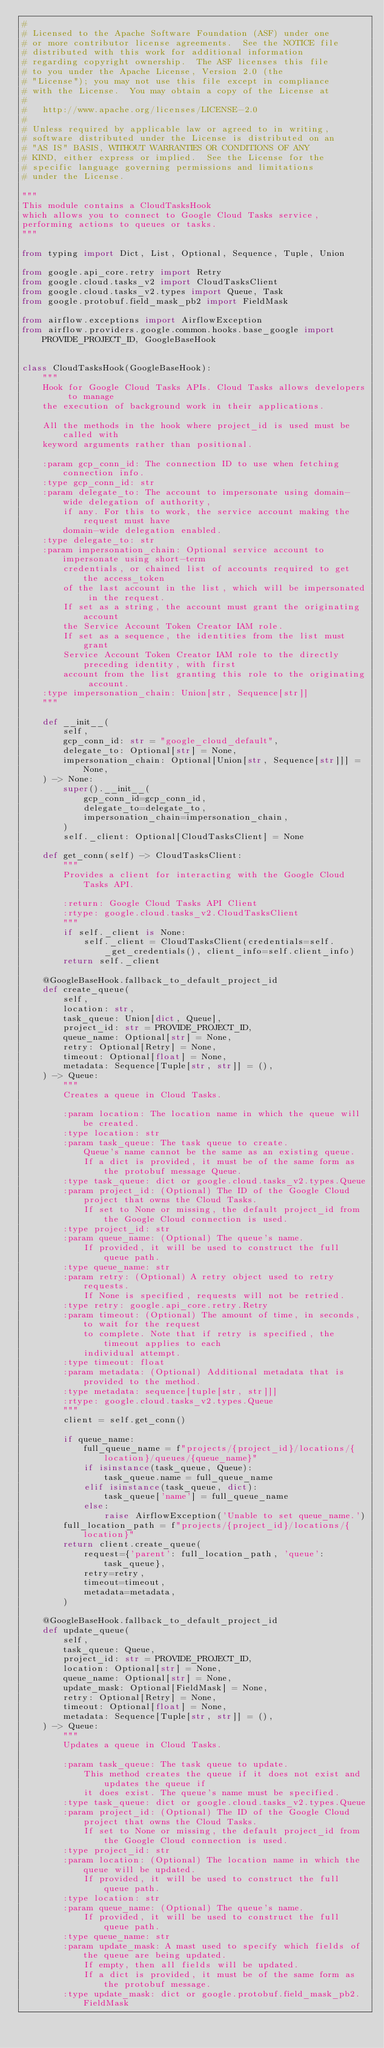Convert code to text. <code><loc_0><loc_0><loc_500><loc_500><_Python_>#
# Licensed to the Apache Software Foundation (ASF) under one
# or more contributor license agreements.  See the NOTICE file
# distributed with this work for additional information
# regarding copyright ownership.  The ASF licenses this file
# to you under the Apache License, Version 2.0 (the
# "License"); you may not use this file except in compliance
# with the License.  You may obtain a copy of the License at
#
#   http://www.apache.org/licenses/LICENSE-2.0
#
# Unless required by applicable law or agreed to in writing,
# software distributed under the License is distributed on an
# "AS IS" BASIS, WITHOUT WARRANTIES OR CONDITIONS OF ANY
# KIND, either express or implied.  See the License for the
# specific language governing permissions and limitations
# under the License.

"""
This module contains a CloudTasksHook
which allows you to connect to Google Cloud Tasks service,
performing actions to queues or tasks.
"""

from typing import Dict, List, Optional, Sequence, Tuple, Union

from google.api_core.retry import Retry
from google.cloud.tasks_v2 import CloudTasksClient
from google.cloud.tasks_v2.types import Queue, Task
from google.protobuf.field_mask_pb2 import FieldMask

from airflow.exceptions import AirflowException
from airflow.providers.google.common.hooks.base_google import PROVIDE_PROJECT_ID, GoogleBaseHook


class CloudTasksHook(GoogleBaseHook):
    """
    Hook for Google Cloud Tasks APIs. Cloud Tasks allows developers to manage
    the execution of background work in their applications.

    All the methods in the hook where project_id is used must be called with
    keyword arguments rather than positional.

    :param gcp_conn_id: The connection ID to use when fetching connection info.
    :type gcp_conn_id: str
    :param delegate_to: The account to impersonate using domain-wide delegation of authority,
        if any. For this to work, the service account making the request must have
        domain-wide delegation enabled.
    :type delegate_to: str
    :param impersonation_chain: Optional service account to impersonate using short-term
        credentials, or chained list of accounts required to get the access_token
        of the last account in the list, which will be impersonated in the request.
        If set as a string, the account must grant the originating account
        the Service Account Token Creator IAM role.
        If set as a sequence, the identities from the list must grant
        Service Account Token Creator IAM role to the directly preceding identity, with first
        account from the list granting this role to the originating account.
    :type impersonation_chain: Union[str, Sequence[str]]
    """

    def __init__(
        self,
        gcp_conn_id: str = "google_cloud_default",
        delegate_to: Optional[str] = None,
        impersonation_chain: Optional[Union[str, Sequence[str]]] = None,
    ) -> None:
        super().__init__(
            gcp_conn_id=gcp_conn_id,
            delegate_to=delegate_to,
            impersonation_chain=impersonation_chain,
        )
        self._client: Optional[CloudTasksClient] = None

    def get_conn(self) -> CloudTasksClient:
        """
        Provides a client for interacting with the Google Cloud Tasks API.

        :return: Google Cloud Tasks API Client
        :rtype: google.cloud.tasks_v2.CloudTasksClient
        """
        if self._client is None:
            self._client = CloudTasksClient(credentials=self._get_credentials(), client_info=self.client_info)
        return self._client

    @GoogleBaseHook.fallback_to_default_project_id
    def create_queue(
        self,
        location: str,
        task_queue: Union[dict, Queue],
        project_id: str = PROVIDE_PROJECT_ID,
        queue_name: Optional[str] = None,
        retry: Optional[Retry] = None,
        timeout: Optional[float] = None,
        metadata: Sequence[Tuple[str, str]] = (),
    ) -> Queue:
        """
        Creates a queue in Cloud Tasks.

        :param location: The location name in which the queue will be created.
        :type location: str
        :param task_queue: The task queue to create.
            Queue's name cannot be the same as an existing queue.
            If a dict is provided, it must be of the same form as the protobuf message Queue.
        :type task_queue: dict or google.cloud.tasks_v2.types.Queue
        :param project_id: (Optional) The ID of the Google Cloud project that owns the Cloud Tasks.
            If set to None or missing, the default project_id from the Google Cloud connection is used.
        :type project_id: str
        :param queue_name: (Optional) The queue's name.
            If provided, it will be used to construct the full queue path.
        :type queue_name: str
        :param retry: (Optional) A retry object used to retry requests.
            If None is specified, requests will not be retried.
        :type retry: google.api_core.retry.Retry
        :param timeout: (Optional) The amount of time, in seconds, to wait for the request
            to complete. Note that if retry is specified, the timeout applies to each
            individual attempt.
        :type timeout: float
        :param metadata: (Optional) Additional metadata that is provided to the method.
        :type metadata: sequence[tuple[str, str]]]
        :rtype: google.cloud.tasks_v2.types.Queue
        """
        client = self.get_conn()

        if queue_name:
            full_queue_name = f"projects/{project_id}/locations/{location}/queues/{queue_name}"
            if isinstance(task_queue, Queue):
                task_queue.name = full_queue_name
            elif isinstance(task_queue, dict):
                task_queue['name'] = full_queue_name
            else:
                raise AirflowException('Unable to set queue_name.')
        full_location_path = f"projects/{project_id}/locations/{location}"
        return client.create_queue(
            request={'parent': full_location_path, 'queue': task_queue},
            retry=retry,
            timeout=timeout,
            metadata=metadata,
        )

    @GoogleBaseHook.fallback_to_default_project_id
    def update_queue(
        self,
        task_queue: Queue,
        project_id: str = PROVIDE_PROJECT_ID,
        location: Optional[str] = None,
        queue_name: Optional[str] = None,
        update_mask: Optional[FieldMask] = None,
        retry: Optional[Retry] = None,
        timeout: Optional[float] = None,
        metadata: Sequence[Tuple[str, str]] = (),
    ) -> Queue:
        """
        Updates a queue in Cloud Tasks.

        :param task_queue: The task queue to update.
            This method creates the queue if it does not exist and updates the queue if
            it does exist. The queue's name must be specified.
        :type task_queue: dict or google.cloud.tasks_v2.types.Queue
        :param project_id: (Optional) The ID of the Google Cloud project that owns the Cloud Tasks.
            If set to None or missing, the default project_id from the Google Cloud connection is used.
        :type project_id: str
        :param location: (Optional) The location name in which the queue will be updated.
            If provided, it will be used to construct the full queue path.
        :type location: str
        :param queue_name: (Optional) The queue's name.
            If provided, it will be used to construct the full queue path.
        :type queue_name: str
        :param update_mask: A mast used to specify which fields of the queue are being updated.
            If empty, then all fields will be updated.
            If a dict is provided, it must be of the same form as the protobuf message.
        :type update_mask: dict or google.protobuf.field_mask_pb2.FieldMask</code> 